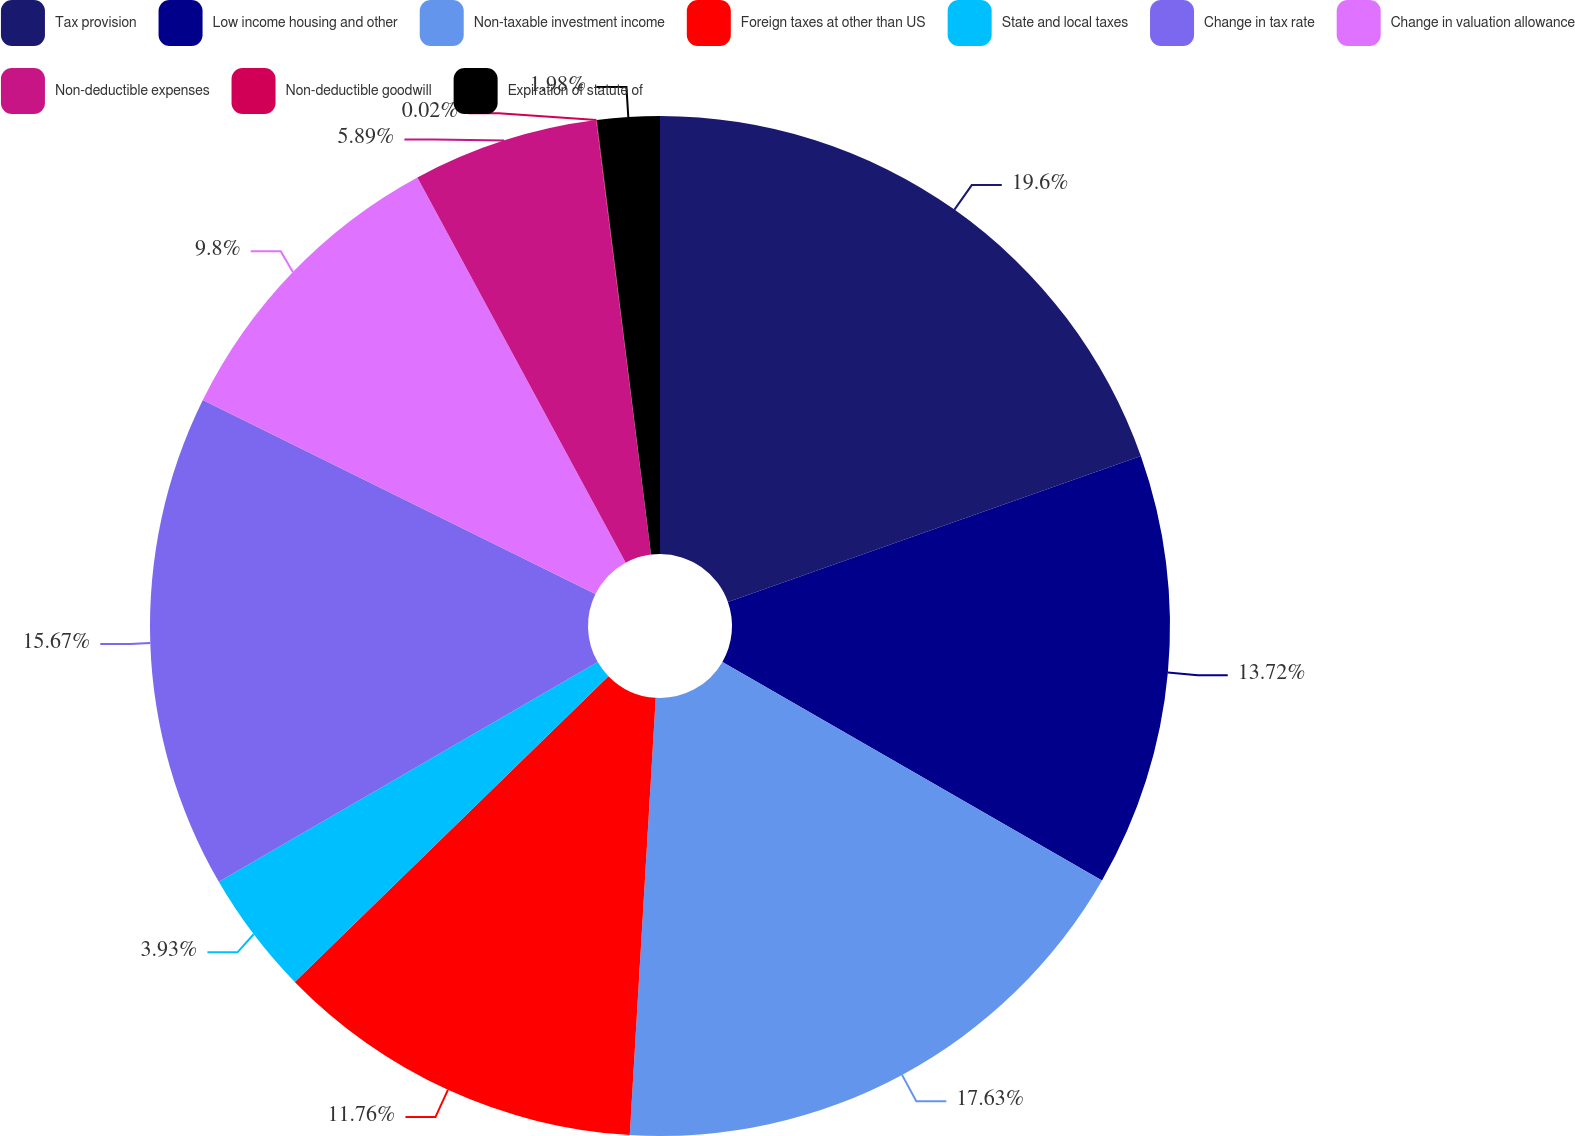Convert chart to OTSL. <chart><loc_0><loc_0><loc_500><loc_500><pie_chart><fcel>Tax provision<fcel>Low income housing and other<fcel>Non-taxable investment income<fcel>Foreign taxes at other than US<fcel>State and local taxes<fcel>Change in tax rate<fcel>Change in valuation allowance<fcel>Non-deductible expenses<fcel>Non-deductible goodwill<fcel>Expiration of statute of<nl><fcel>19.59%<fcel>13.72%<fcel>17.63%<fcel>11.76%<fcel>3.93%<fcel>15.67%<fcel>9.8%<fcel>5.89%<fcel>0.02%<fcel>1.98%<nl></chart> 